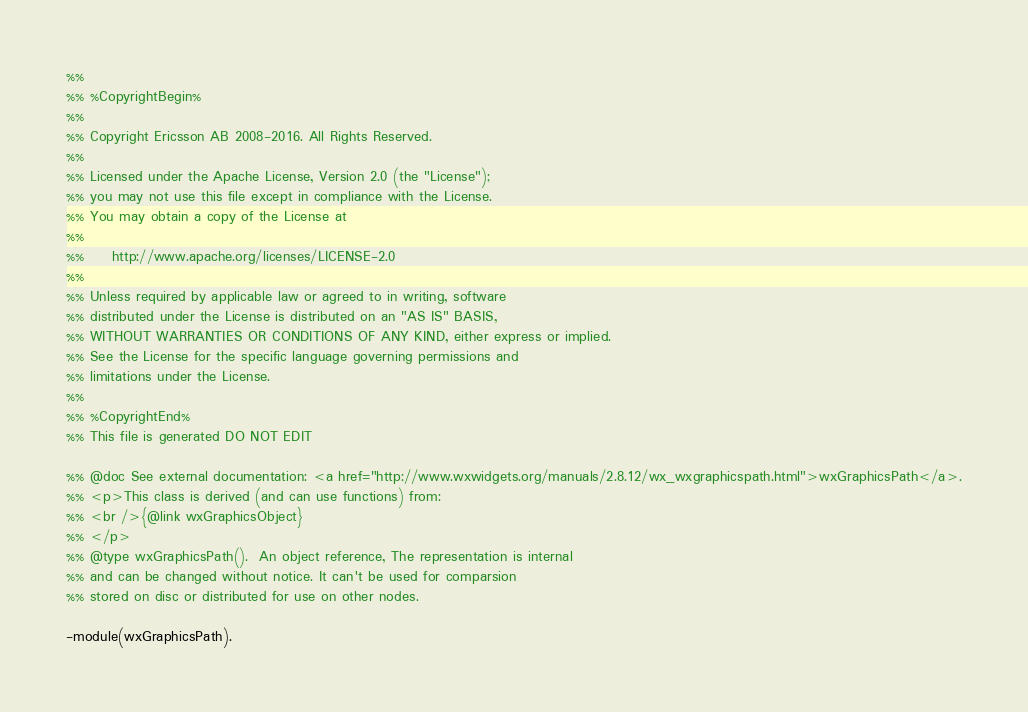Convert code to text. <code><loc_0><loc_0><loc_500><loc_500><_Erlang_>%%
%% %CopyrightBegin%
%%
%% Copyright Ericsson AB 2008-2016. All Rights Reserved.
%%
%% Licensed under the Apache License, Version 2.0 (the "License");
%% you may not use this file except in compliance with the License.
%% You may obtain a copy of the License at
%%
%%     http://www.apache.org/licenses/LICENSE-2.0
%%
%% Unless required by applicable law or agreed to in writing, software
%% distributed under the License is distributed on an "AS IS" BASIS,
%% WITHOUT WARRANTIES OR CONDITIONS OF ANY KIND, either express or implied.
%% See the License for the specific language governing permissions and
%% limitations under the License.
%%
%% %CopyrightEnd%
%% This file is generated DO NOT EDIT

%% @doc See external documentation: <a href="http://www.wxwidgets.org/manuals/2.8.12/wx_wxgraphicspath.html">wxGraphicsPath</a>.
%% <p>This class is derived (and can use functions) from:
%% <br />{@link wxGraphicsObject}
%% </p>
%% @type wxGraphicsPath().  An object reference, The representation is internal
%% and can be changed without notice. It can't be used for comparsion
%% stored on disc or distributed for use on other nodes.

-module(wxGraphicsPath).</code> 